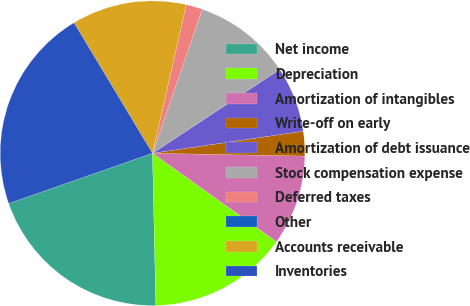Convert chart to OTSL. <chart><loc_0><loc_0><loc_500><loc_500><pie_chart><fcel>Net income<fcel>Depreciation<fcel>Amortization of intangibles<fcel>Write-off on early<fcel>Amortization of debt issuance<fcel>Stock compensation expense<fcel>Deferred taxes<fcel>Other<fcel>Accounts receivable<fcel>Inventories<nl><fcel>20.0%<fcel>14.78%<fcel>9.57%<fcel>2.61%<fcel>6.96%<fcel>10.43%<fcel>1.74%<fcel>0.0%<fcel>12.17%<fcel>21.73%<nl></chart> 